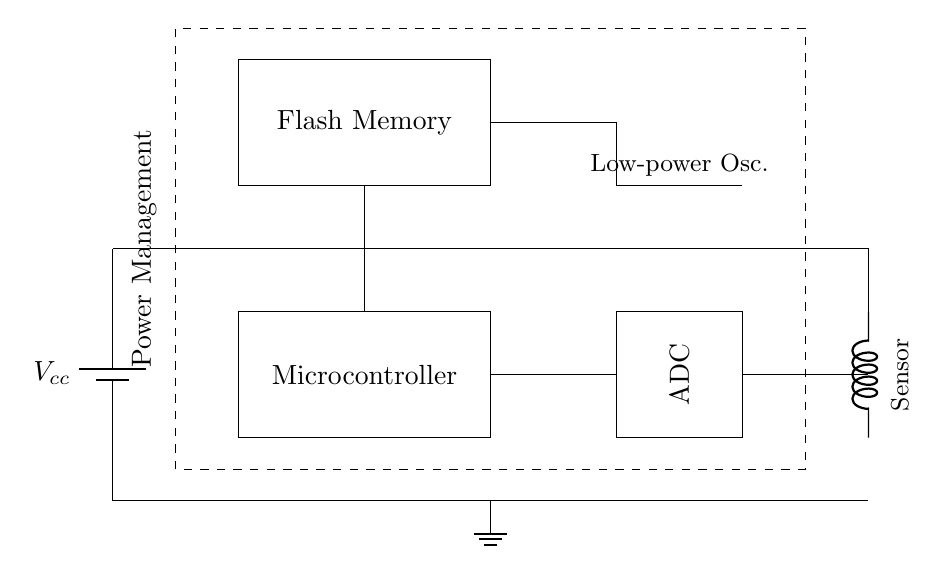What is the primary function of the microcontroller? The microcontroller is responsible for processing data collected from the sensor and controlling the overall operation of the circuit.
Answer: Processing data What type of memory is used in this circuit? The circuit uses Flash Memory, which is indicated as the memory block in the diagram and is suitable for storing data in a low-power environment.
Answer: Flash Memory How many components are connected to the power supply? There are five components connected to the power supply: the microcontroller, ADC, sensor, flash memory, and oscillator, all of which are linked directly or indirectly to the power line.
Answer: Five What type of oscillator is used in this circuit? A low-power oscillator is used, which is specified in the circuit diagram, indicating its focus on energy efficiency for long-term operation.
Answer: Low-power What is the potential role of the analog-to-digital converter? The ADC converts analog signals from the sensor into digital data that can be processed by the microcontroller, facilitating the data logging process in the circuit.
Answer: Conversion of signals What is the purpose of power management in this circuit? Power management is essential for regulating the energy consumption and ensuring the efficiency of the low-power circuit, as indicated by the dashed rectangle encompassing several components.
Answer: Regulating energy consumption Which component would primarily determine the sampling rate of data logging? The microcontroller would primarily determine the sampling rate, as it governs the timing of data collection and processing from the sensor and ADC.
Answer: Microcontroller 